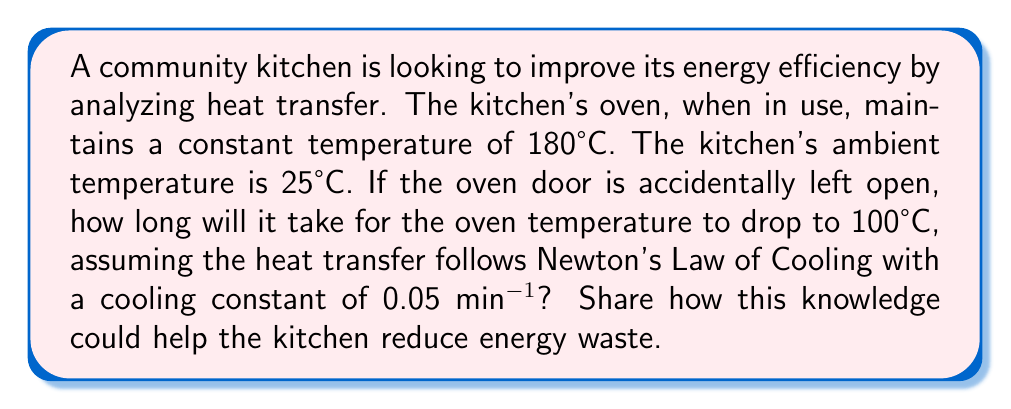Show me your answer to this math problem. Let's approach this step-by-step using Newton's Law of Cooling:

1) Newton's Law of Cooling is given by:
   $$\frac{dT}{dt} = -k(T - T_a)$$
   where $T$ is the temperature of the object, $T_a$ is the ambient temperature, $t$ is time, and $k$ is the cooling constant.

2) The solution to this differential equation is:
   $$T(t) = T_a + (T_0 - T_a)e^{-kt}$$
   where $T_0$ is the initial temperature.

3) We have:
   $T_0 = 180°C$ (initial oven temperature)
   $T_a = 25°C$ (ambient temperature)
   $T(t) = 100°C$ (final temperature we're solving for)
   $k = 0.05 \text{ min}^{-1}$ (cooling constant)

4) Plugging these into our equation:
   $$100 = 25 + (180 - 25)e^{-0.05t}$$

5) Simplifying:
   $$75 = 155e^{-0.05t}$$

6) Taking natural log of both sides:
   $$\ln(\frac{75}{155}) = -0.05t$$

7) Solving for $t$:
   $$t = -\frac{1}{0.05}\ln(\frac{75}{155}) \approx 14.73 \text{ minutes}$$

This knowledge can help the kitchen reduce energy waste by highlighting the importance of keeping the oven door closed. Even a short period with the door open can lead to significant temperature drops, requiring more energy to reheat the oven. Implementing a policy to keep oven doors closed when not in use and possibly installing auto-close mechanisms could greatly improve energy efficiency.
Answer: 14.73 minutes 